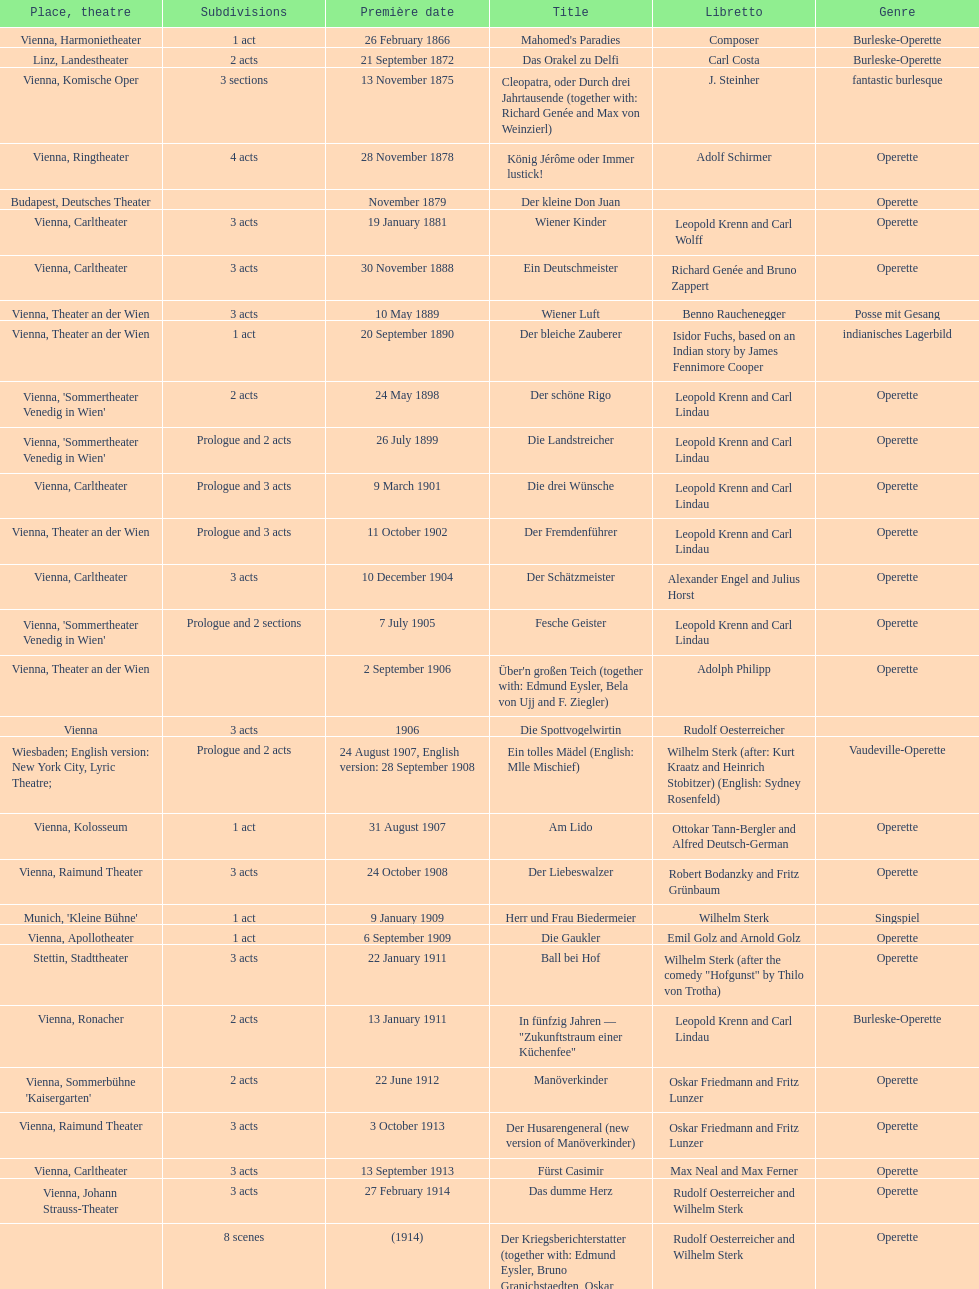What was the year of the last title? 1958. 